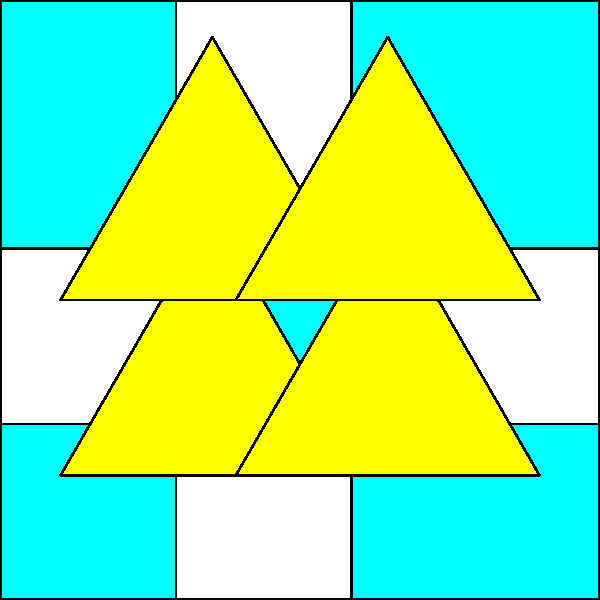A book cover designer has created a geometric pattern using squares and equilateral triangles, as shown in the image. If the side length of each square is 2 cm, what is the total area of the yellow regions in square centimeters? Let's approach this step-by-step:

1) First, we need to find the area of one equilateral triangle:
   - The side length of the triangle is the same as the square's diagonal
   - The diagonal of a 2 cm square is $2\sqrt{2}$ cm (using the Pythagorean theorem)
   - The area of an equilateral triangle with side $s$ is $\frac{\sqrt{3}}{4}s^2$
   - So, the area of one triangle is $\frac{\sqrt{3}}{4}(2\sqrt{2})^2 = 2\sqrt{3}$ cm²

2) Now, let's count how many yellow triangles there are:
   - There are 4 yellow triangles in the pattern

3) Therefore, the total yellow area is:
   $4 * 2\sqrt{3} = 8\sqrt{3}$ cm²
Answer: $8\sqrt{3}$ cm² 